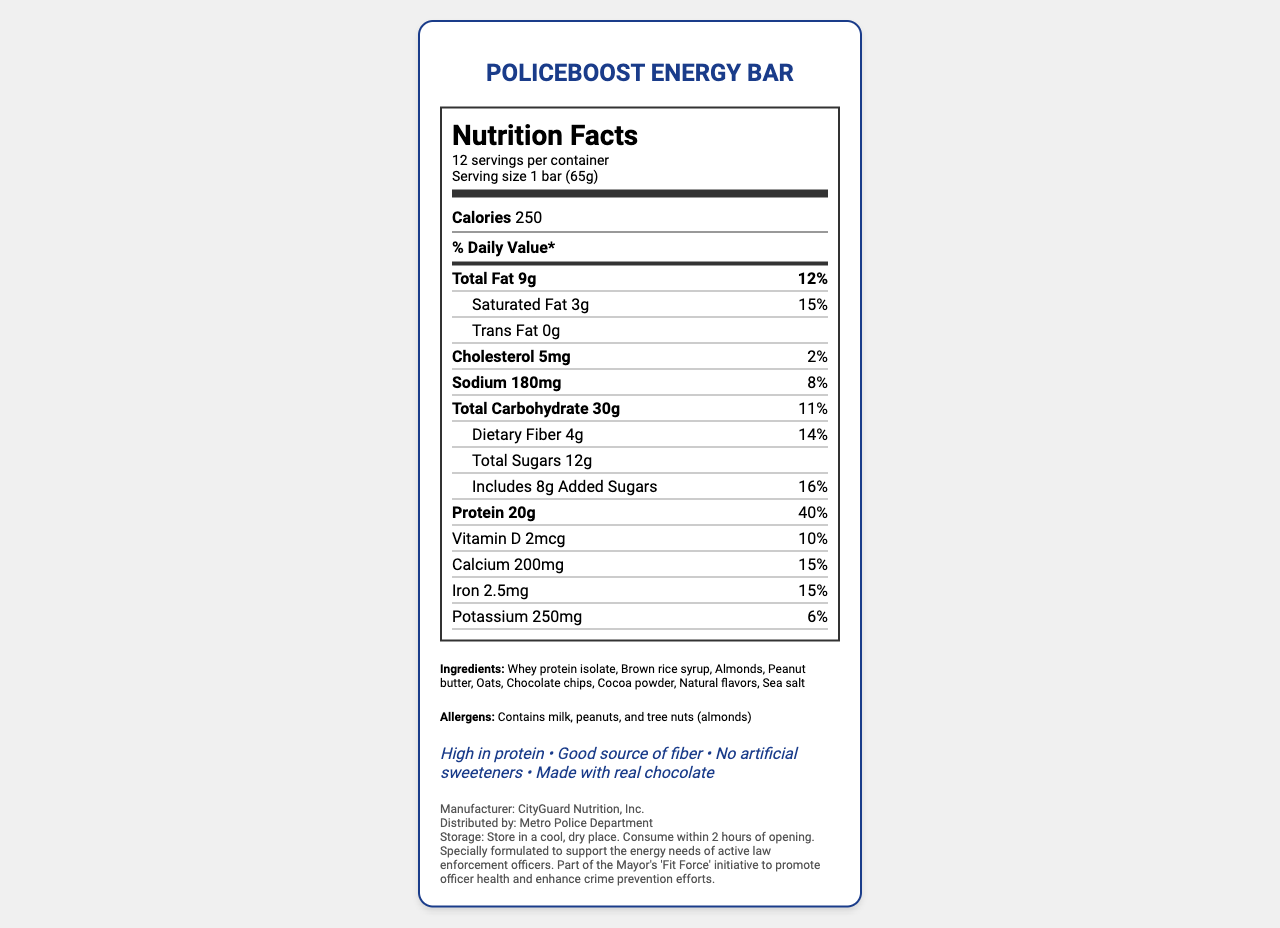what is the total fat content per serving? The document lists the total fat content as 9g per serving.
Answer: 9g what percentage of the daily value for protein is in one bar? The document states that the daily value for protein in one bar is 40%.
Answer: 40% which company manufactures the PoliceBoost Energy Bar? The document specifies that the manufacturer is CityGuard Nutrition, Inc.
Answer: CityGuard Nutrition, Inc. how many calories are in one serving? The document lists the calorie content as 250 per serving.
Answer: 250 what allergens does the energy bar contain? The document mentions that the allergens are milk, peanuts, and tree nuts (almonds).
Answer: Contains milk, peanuts, and tree nuts (almonds) how much sodium is in one serving? The document lists the sodium content as 180mg per serving.
Answer: 180mg what is the serving size of the PoliceBoost Energy Bar? A. 50g B. 65g C. 70g D. 80g The document specifies the serving size is 1 bar (65g).
Answer: B which nutrient has the highest daily value percentage in one bar? A. Total Fat B. Calcium C. Vitamin D D. Protein The document shows that protein has the highest daily value percentage at 40%.
Answer: D is the PoliceBoost Energy Bar high in protein? The document has a claim stating that the bar is high in protein.
Answer: Yes what are the main ingredients in the PoliceBoost Energy Bar? The document lists these as the main ingredients in the energy bar.
Answer: Whey protein isolate, brown rice syrup, almonds, peanut butter, oats, chocolate chips, cocoa powder, natural flavors, sea salt does the product contain any artificial sweeteners? The document includes a claim that states there are no artificial sweeteners in the product.
Answer: No summarize the key features and nutritional information of the PoliceBoost Energy Bar. The document’s layout includes all these details, making it clear and concise.
Answer: The PoliceBoost Energy Bar is manufactured by CityGuard Nutrition, Inc., and distributed by the Metro Police Department. It has a serving size of 1 bar (65g) with 12 servings per container. Each bar contains 250 calories, with significant contributions from fat (9g), protein (20g), and carbohydrates (30g). The bar provides high nutritional value, especially in protein (40% DV) and fiber (14% DV). It includes ingredients like whey protein isolate, brown rice syrup, and almonds. The product is free from artificial sweeteners and highlights claims such as being high in protein and made with real chocolate. Allergen information mentions the presence of milk, peanuts, and tree nuts (almonds). is the PoliceBoost Energy Bar part of any specific initiative? The document mentions it is part of the Mayor's "Fit Force" initiative to promote officer health and enhance crime prevention efforts.
Answer: Yes what is the recommended storage condition for the PoliceBoost Energy Bar? The document provides these storage instructions for the energy bar.
Answer: Store in a cool, dry place. Consume within 2 hours of opening. how much dietary fiber does each PoliceBoost Energy Bar contain? The document lists the dietary fiber content as 4g per serving.
Answer: 4g how many calories come from fat in one serving? The document does not provide information on the specific calorie count from fat.
Answer: Not enough information based on the nutrition label, which organization is likely focused on enhancing the energy and health of police officers? The document indicates that the bars are distributed by the Metro Police Department and are specially formulated for law enforcement officers.
Answer: Metro Police Department 